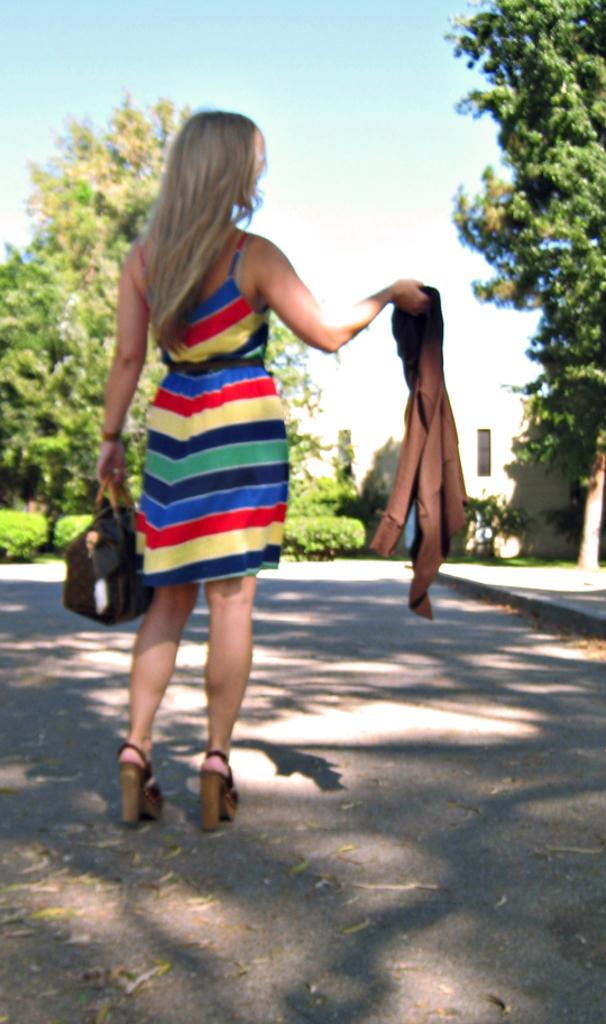Who is present in the image? There is a woman in the image. What is the woman holding in the image? The woman is holding a bag and a jacket. What can be seen in the background of the image? There is a house and trees in the background of the image. What type of sticks are the woman using to plant flowers in the image? There are no sticks or flowers present in the image. 